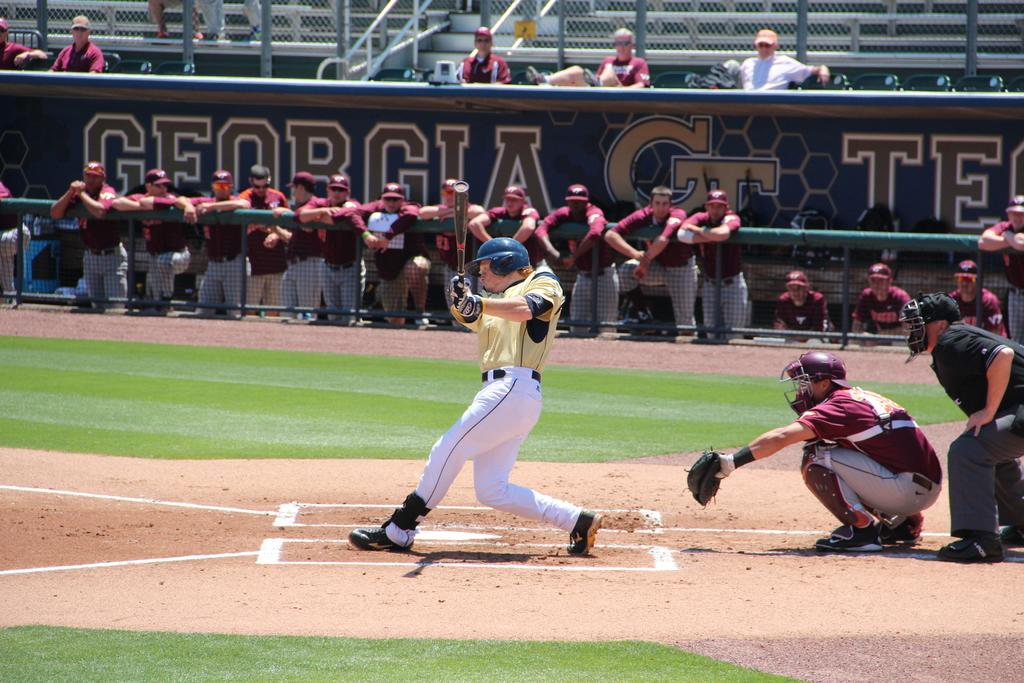Provide a one-sentence caption for the provided image. Georgia is the state for one of the baseball teams playing. 